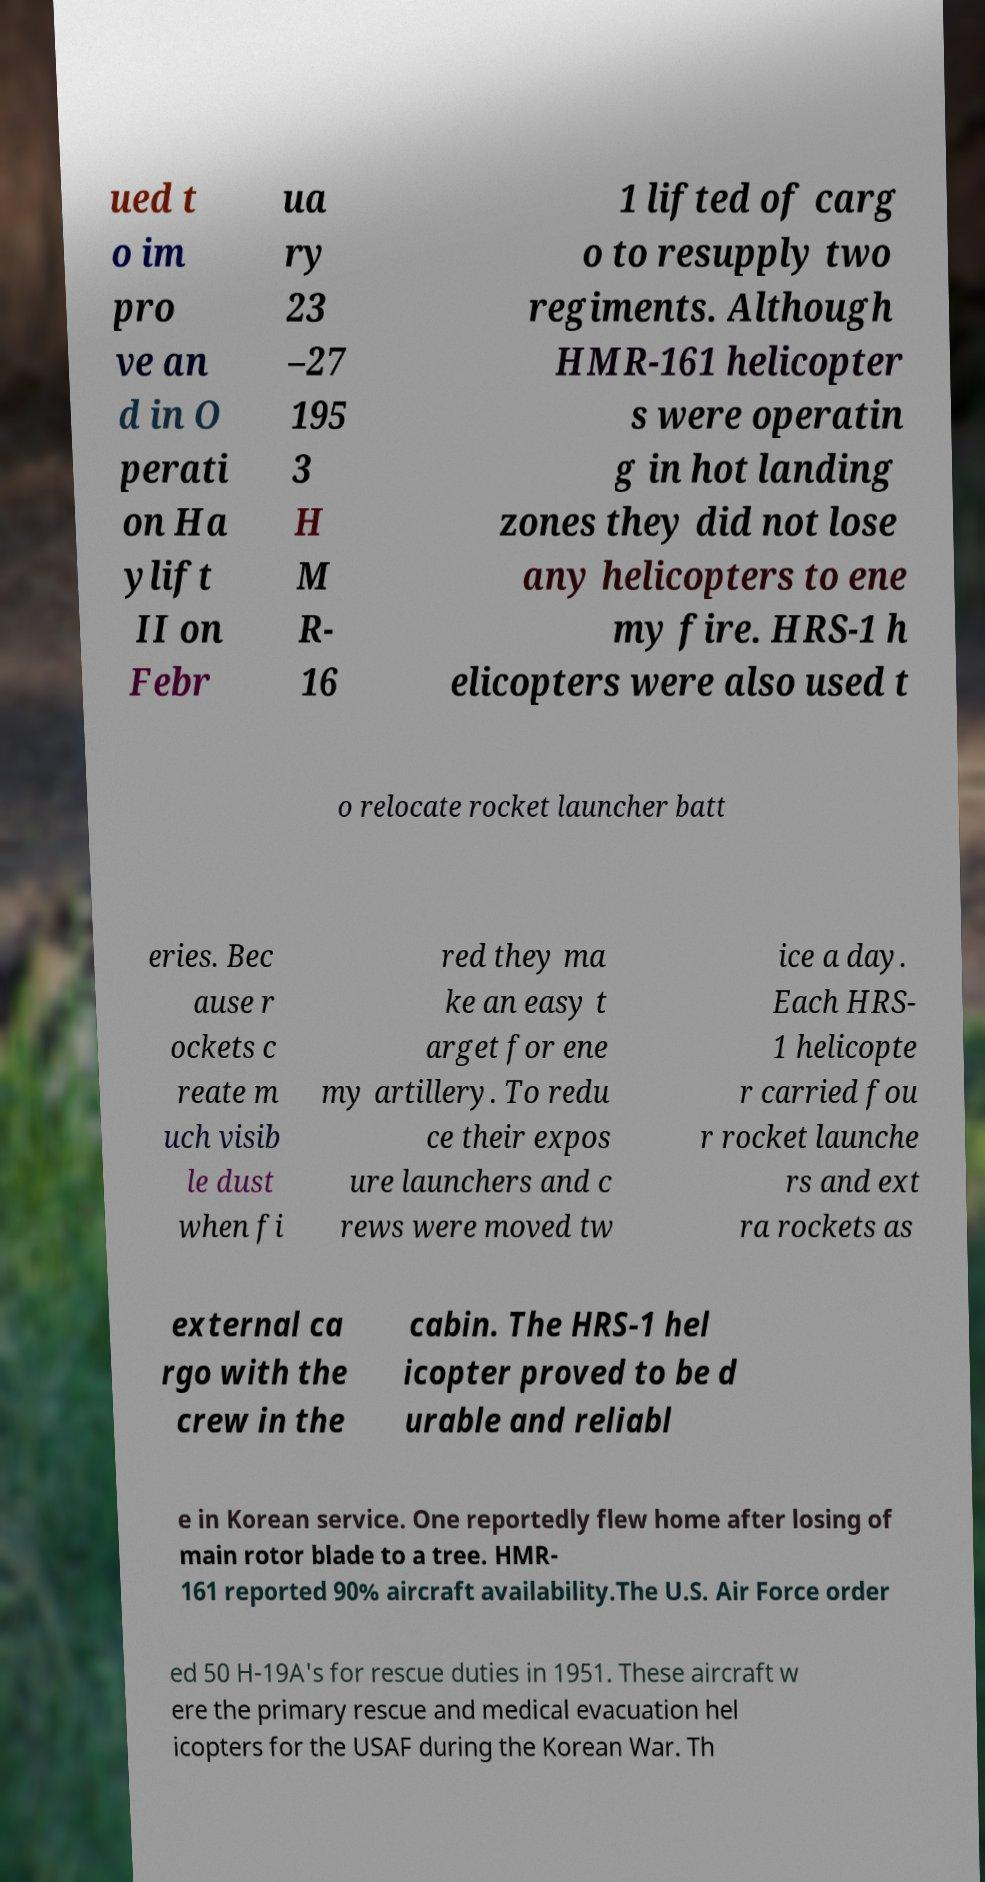There's text embedded in this image that I need extracted. Can you transcribe it verbatim? ued t o im pro ve an d in O perati on Ha ylift II on Febr ua ry 23 –27 195 3 H M R- 16 1 lifted of carg o to resupply two regiments. Although HMR-161 helicopter s were operatin g in hot landing zones they did not lose any helicopters to ene my fire. HRS-1 h elicopters were also used t o relocate rocket launcher batt eries. Bec ause r ockets c reate m uch visib le dust when fi red they ma ke an easy t arget for ene my artillery. To redu ce their expos ure launchers and c rews were moved tw ice a day. Each HRS- 1 helicopte r carried fou r rocket launche rs and ext ra rockets as external ca rgo with the crew in the cabin. The HRS-1 hel icopter proved to be d urable and reliabl e in Korean service. One reportedly flew home after losing of main rotor blade to a tree. HMR- 161 reported 90% aircraft availability.The U.S. Air Force order ed 50 H-19A's for rescue duties in 1951. These aircraft w ere the primary rescue and medical evacuation hel icopters for the USAF during the Korean War. Th 